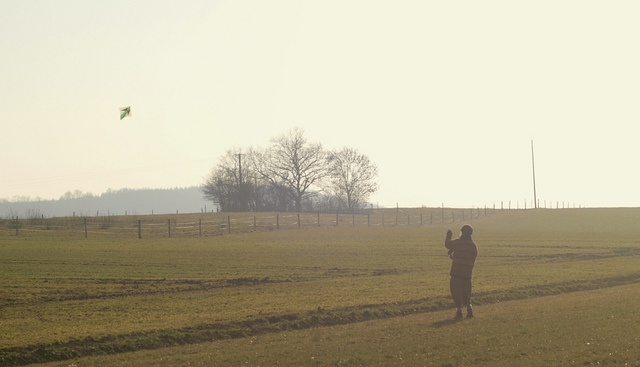Describe the objects in this image and their specific colors. I can see people in beige and gray tones and kite in beige, darkgray, and tan tones in this image. 